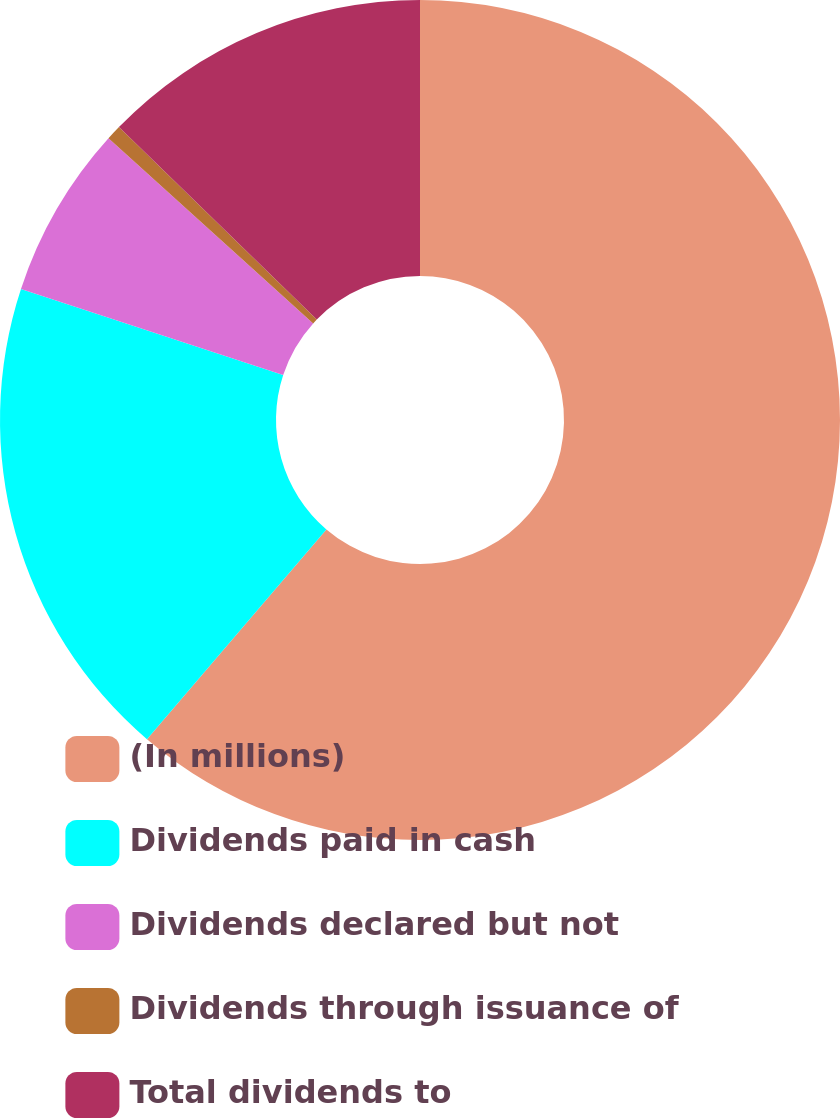<chart> <loc_0><loc_0><loc_500><loc_500><pie_chart><fcel>(In millions)<fcel>Dividends paid in cash<fcel>Dividends declared but not<fcel>Dividends through issuance of<fcel>Total dividends to<nl><fcel>61.27%<fcel>18.79%<fcel>6.65%<fcel>0.58%<fcel>12.72%<nl></chart> 